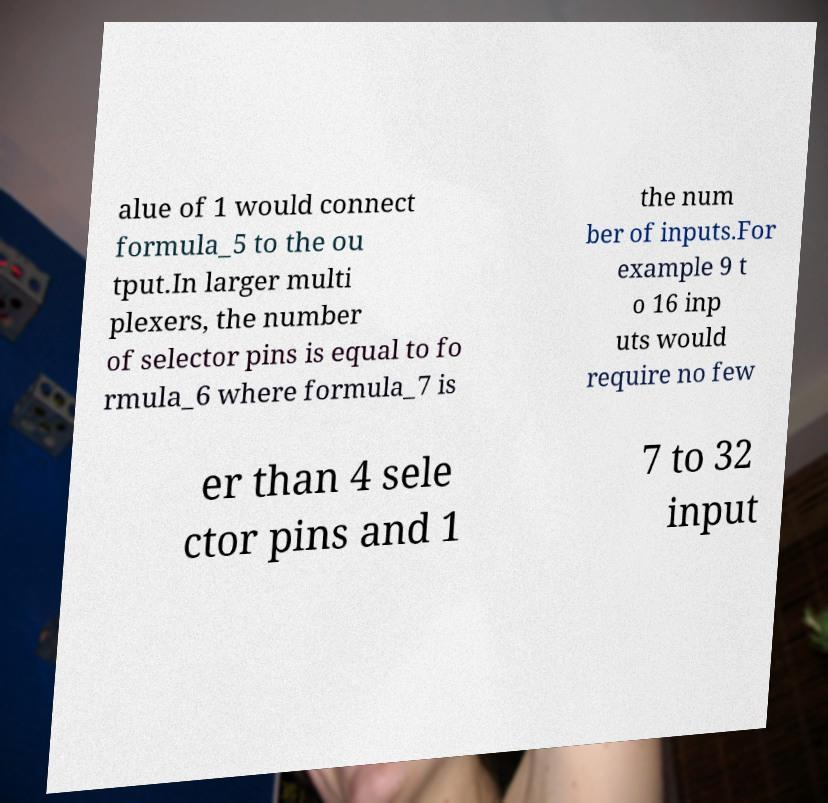What messages or text are displayed in this image? I need them in a readable, typed format. alue of 1 would connect formula_5 to the ou tput.In larger multi plexers, the number of selector pins is equal to fo rmula_6 where formula_7 is the num ber of inputs.For example 9 t o 16 inp uts would require no few er than 4 sele ctor pins and 1 7 to 32 input 